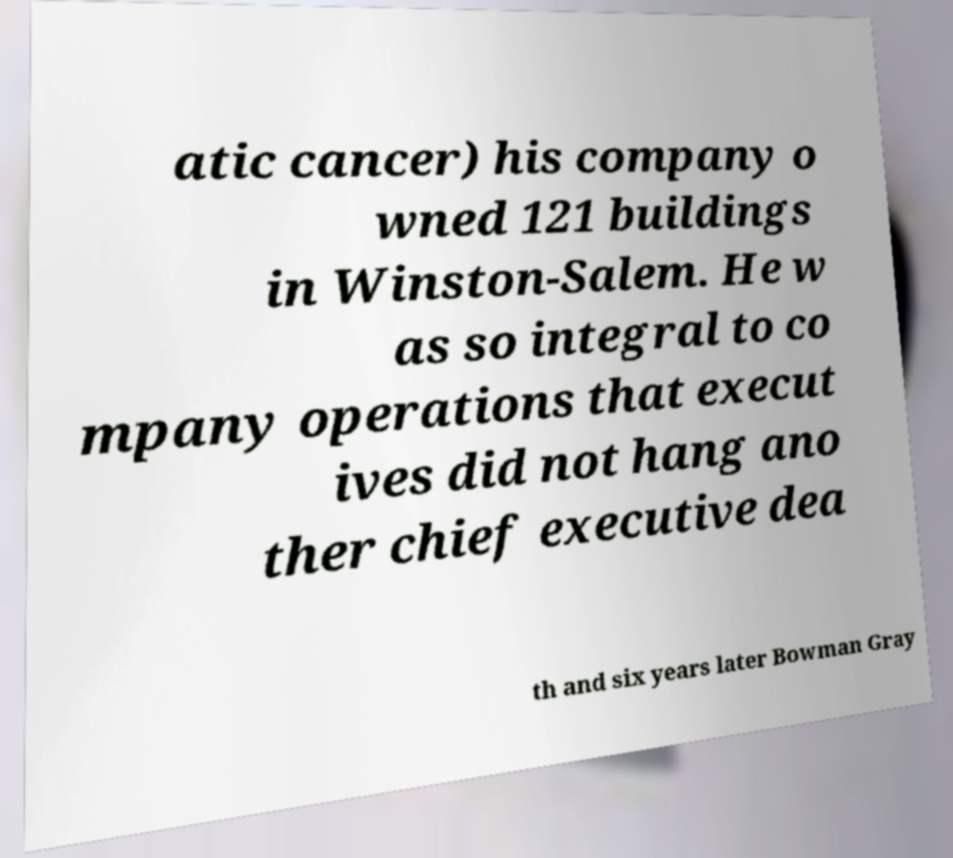Can you accurately transcribe the text from the provided image for me? atic cancer) his company o wned 121 buildings in Winston-Salem. He w as so integral to co mpany operations that execut ives did not hang ano ther chief executive dea th and six years later Bowman Gray 